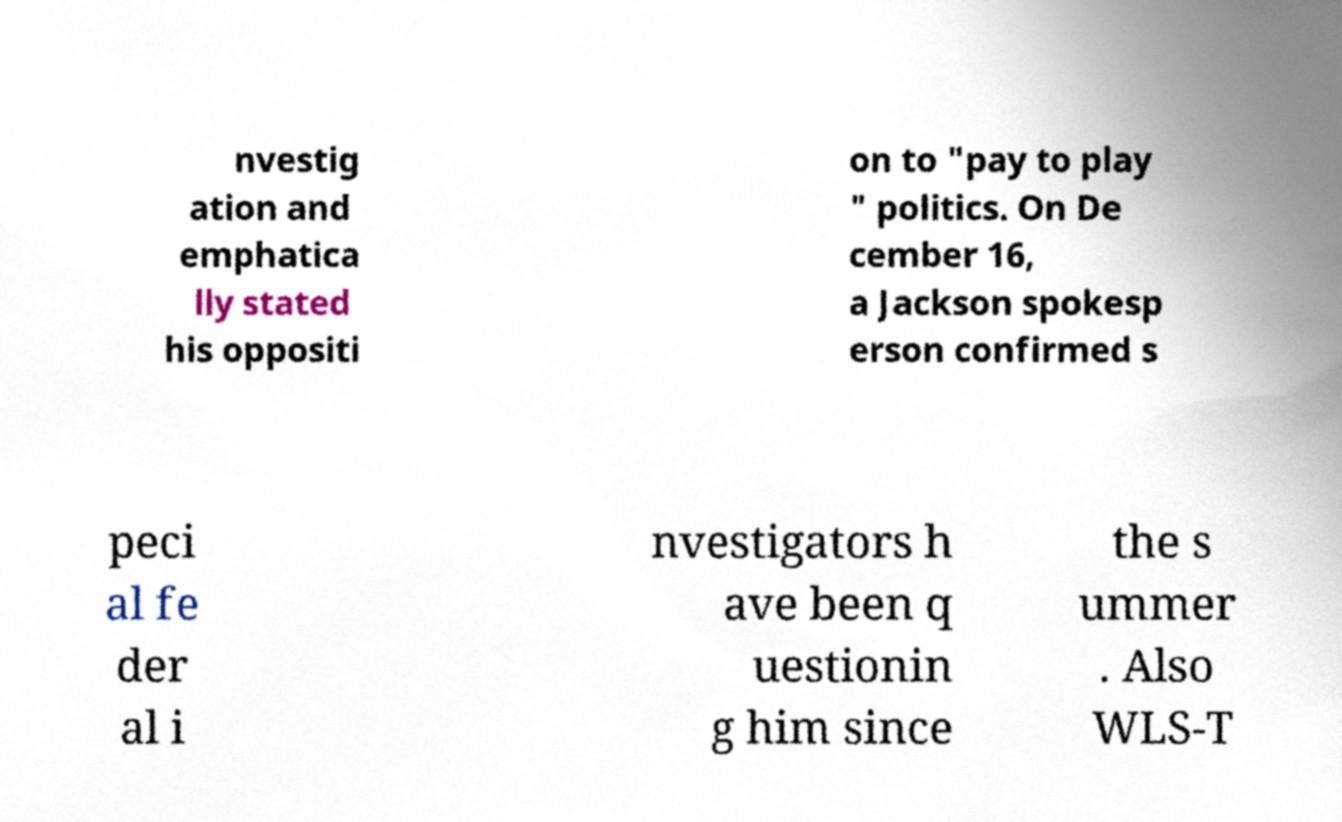Please read and relay the text visible in this image. What does it say? nvestig ation and emphatica lly stated his oppositi on to "pay to play " politics. On De cember 16, a Jackson spokesp erson confirmed s peci al fe der al i nvestigators h ave been q uestionin g him since the s ummer . Also WLS-T 